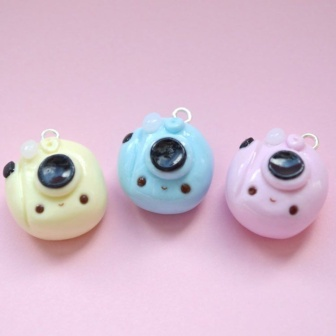What do you see happening in this image? In the image, there are three adorable, round charms designed to look like birds placed on a pastel pink background. Each charm has a unique pastel color: the leftmost is a soft yellow, the middle one is a light blue, and the rightmost is a delicate pink. These bird-shaped charms have cute, round black eyes and small black beaks, with tiny white wings on their sides and loops on top of their heads, indicating they are designed to be hung. Their arrangement is orderly, creating a pleasing and harmonious visual effect. While the birds are static, their charming pastel colors and endearing faces give the image a sense of calmness and delight. The absence of text and other elements keeps the focus solely on these charming characters. 